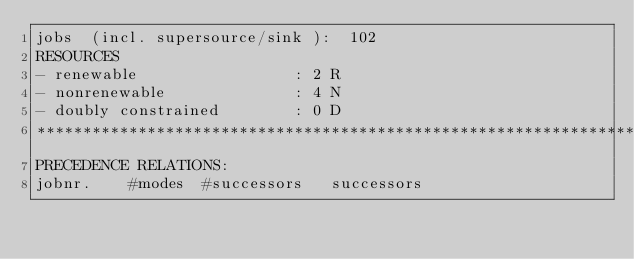Convert code to text. <code><loc_0><loc_0><loc_500><loc_500><_ObjectiveC_>jobs  (incl. supersource/sink ):	102
RESOURCES
- renewable                 : 2 R
- nonrenewable              : 4 N
- doubly constrained        : 0 D
************************************************************************
PRECEDENCE RELATIONS:
jobnr.    #modes  #successors   successors</code> 